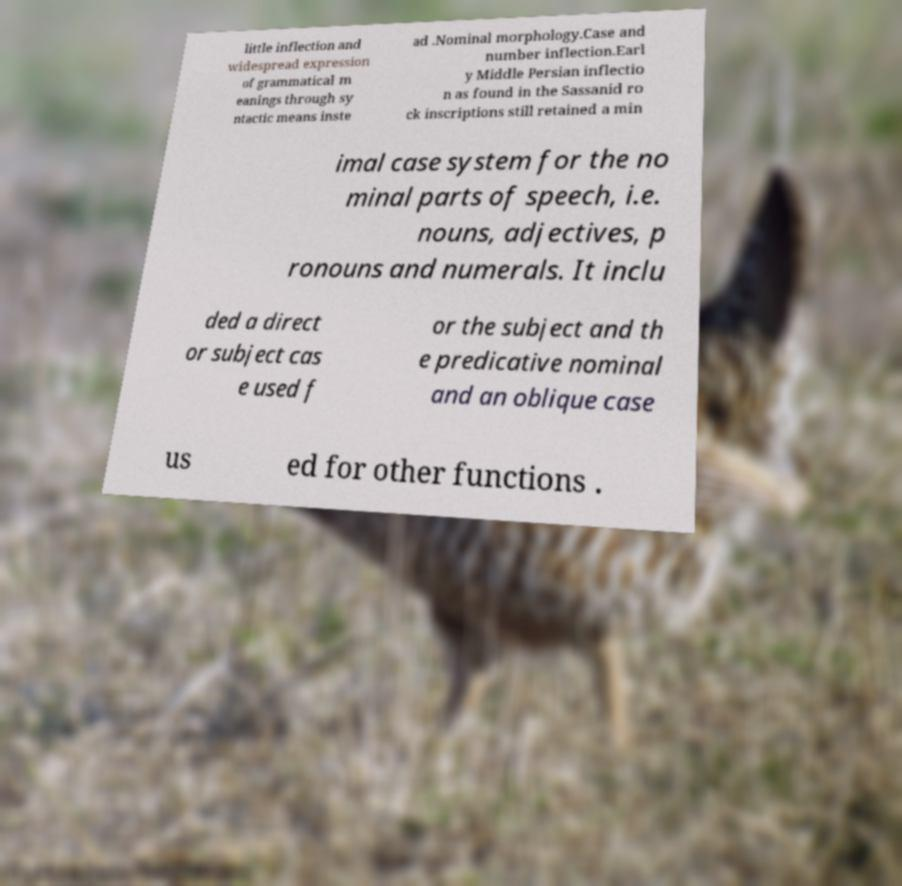Please read and relay the text visible in this image. What does it say? little inflection and widespread expression of grammatical m eanings through sy ntactic means inste ad .Nominal morphology.Case and number inflection.Earl y Middle Persian inflectio n as found in the Sassanid ro ck inscriptions still retained a min imal case system for the no minal parts of speech, i.e. nouns, adjectives, p ronouns and numerals. It inclu ded a direct or subject cas e used f or the subject and th e predicative nominal and an oblique case us ed for other functions . 